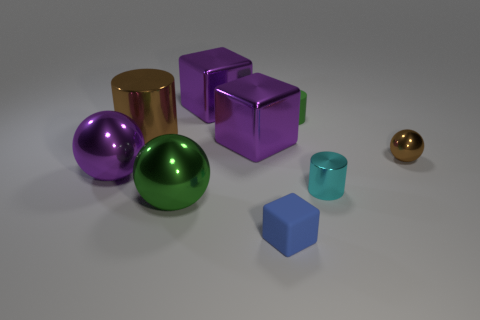Do the purple object that is behind the brown cylinder and the matte thing that is behind the tiny matte cube have the same shape?
Offer a terse response. No. There is a green metal sphere; is it the same size as the rubber object in front of the tiny cyan metallic cylinder?
Your response must be concise. No. Is the number of cubes greater than the number of large things?
Your response must be concise. No. Are the small brown ball that is to the right of the small blue matte object and the big sphere that is in front of the purple ball made of the same material?
Offer a terse response. Yes. What is the small blue block made of?
Provide a short and direct response. Rubber. Is the number of small blue cubes that are in front of the big purple shiny sphere greater than the number of tiny purple objects?
Offer a very short reply. Yes. What number of brown metal objects are in front of the purple cube behind the small rubber object that is on the right side of the tiny blue matte cube?
Your response must be concise. 2. The ball that is both on the left side of the tiny blue matte block and behind the big green object is made of what material?
Make the answer very short. Metal. What is the color of the small shiny sphere?
Offer a very short reply. Brown. Is the number of purple spheres that are to the right of the blue thing greater than the number of green matte things that are to the left of the small green object?
Offer a terse response. No. 